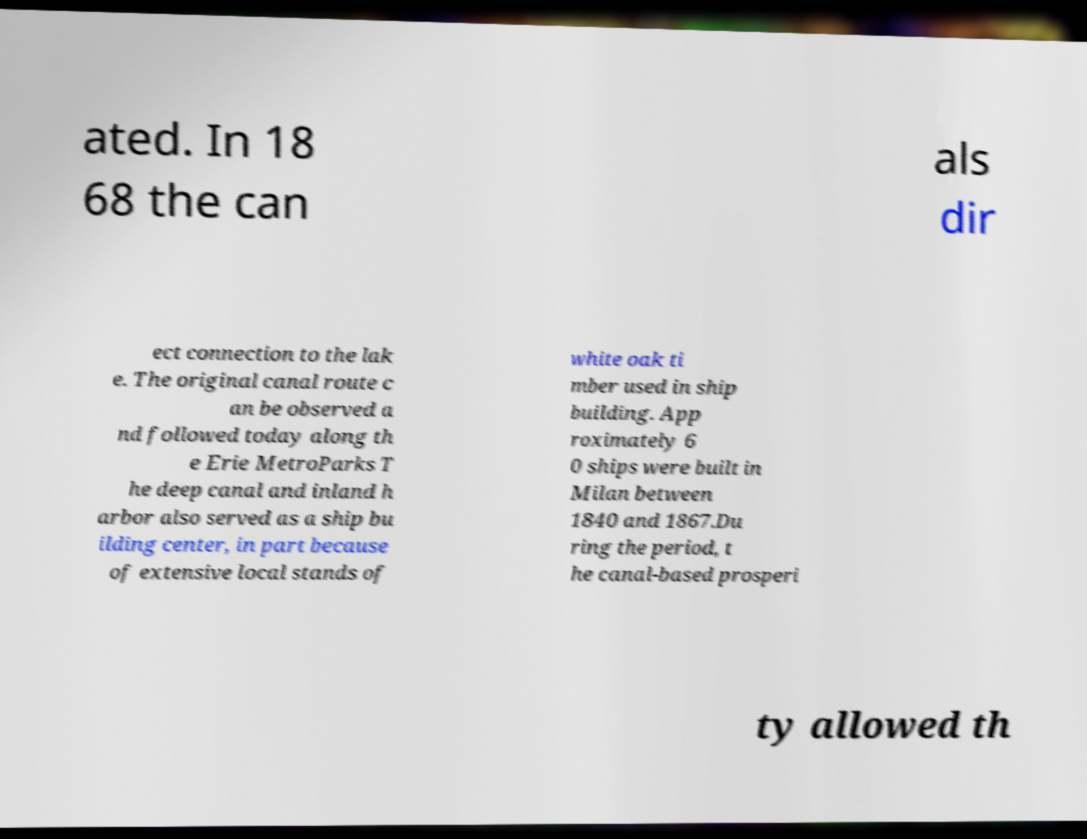Please identify and transcribe the text found in this image. ated. In 18 68 the can als dir ect connection to the lak e. The original canal route c an be observed a nd followed today along th e Erie MetroParks T he deep canal and inland h arbor also served as a ship bu ilding center, in part because of extensive local stands of white oak ti mber used in ship building. App roximately 6 0 ships were built in Milan between 1840 and 1867.Du ring the period, t he canal-based prosperi ty allowed th 